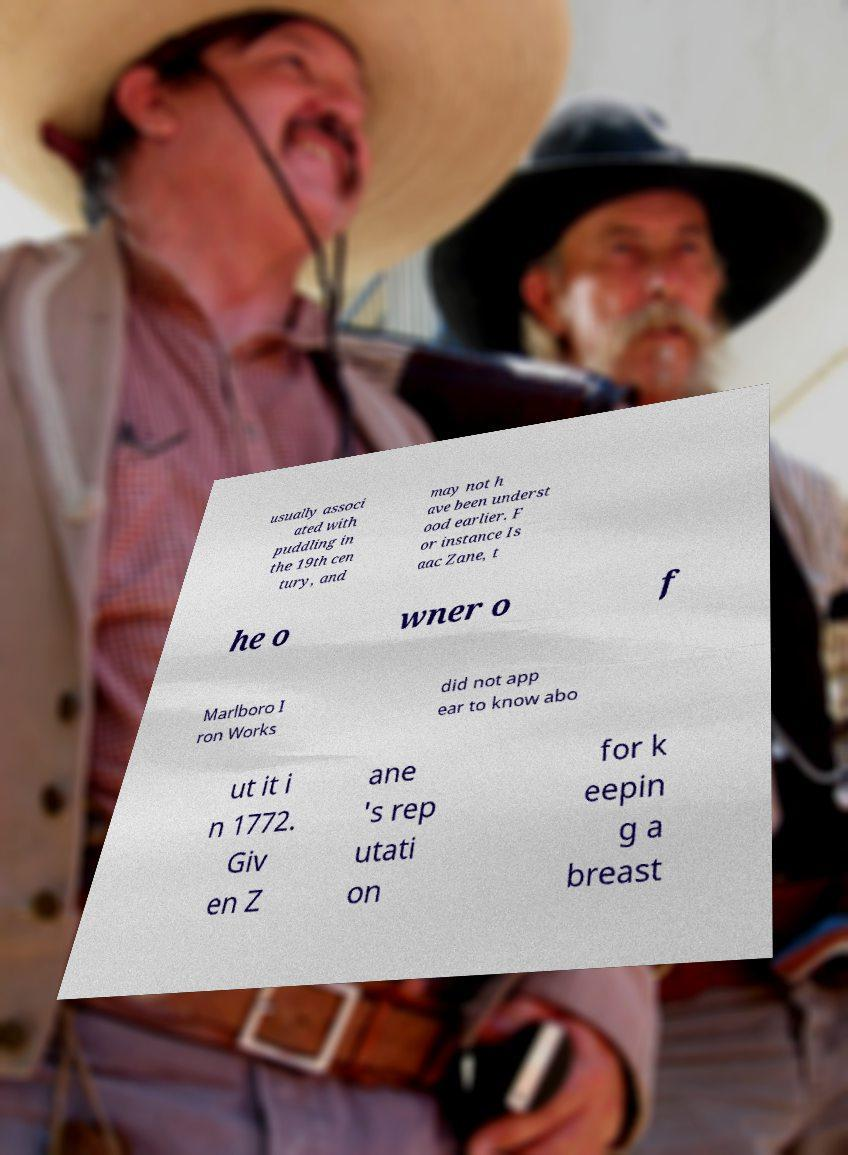Can you accurately transcribe the text from the provided image for me? usually associ ated with puddling in the 19th cen tury, and may not h ave been underst ood earlier. F or instance Is aac Zane, t he o wner o f Marlboro I ron Works did not app ear to know abo ut it i n 1772. Giv en Z ane 's rep utati on for k eepin g a breast 